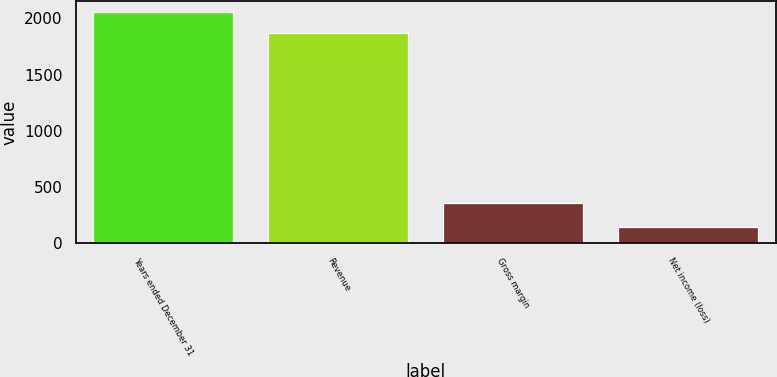Convert chart. <chart><loc_0><loc_0><loc_500><loc_500><bar_chart><fcel>Years ended December 31<fcel>Revenue<fcel>Gross margin<fcel>Net income (loss)<nl><fcel>2054.6<fcel>1868<fcel>355<fcel>146<nl></chart> 